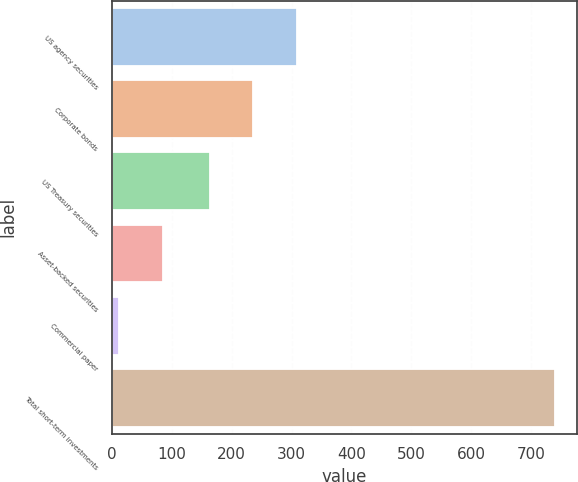Convert chart. <chart><loc_0><loc_0><loc_500><loc_500><bar_chart><fcel>US agency securities<fcel>Corporate bonds<fcel>US Treasury securities<fcel>Asset-backed securities<fcel>Commercial paper<fcel>Total short-term investments<nl><fcel>308.6<fcel>235.8<fcel>163<fcel>84.8<fcel>12<fcel>740<nl></chart> 